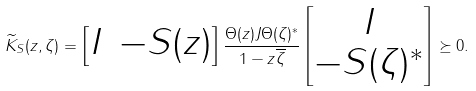Convert formula to latex. <formula><loc_0><loc_0><loc_500><loc_500>\widetilde { K } _ { S } ( z , \zeta ) = \begin{bmatrix} I & - S ( z ) \end{bmatrix} \frac { \Theta ( z ) J \Theta ( \zeta ) ^ { * } } { 1 - z \overline { \zeta } } \begin{bmatrix} I \\ - S ( \zeta ) ^ { * } \end{bmatrix} \succeq 0 .</formula> 